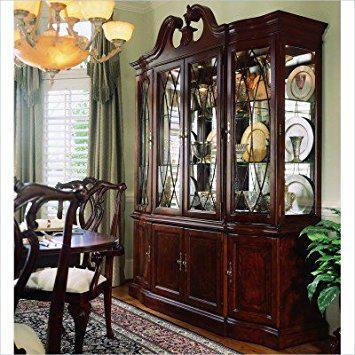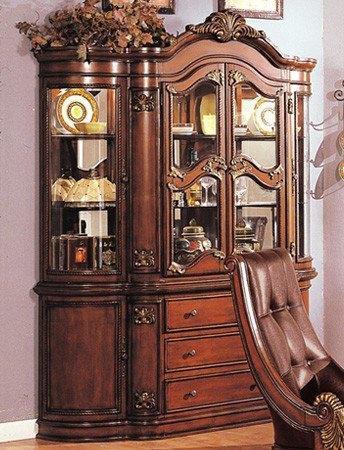The first image is the image on the left, the second image is the image on the right. For the images displayed, is the sentence "Wooden china cabinets in both images are dark and ornate with curved details." factually correct? Answer yes or no. Yes. The first image is the image on the left, the second image is the image on the right. Evaluate the accuracy of this statement regarding the images: "There is a brown chair with white seat.". Is it true? Answer yes or no. Yes. 